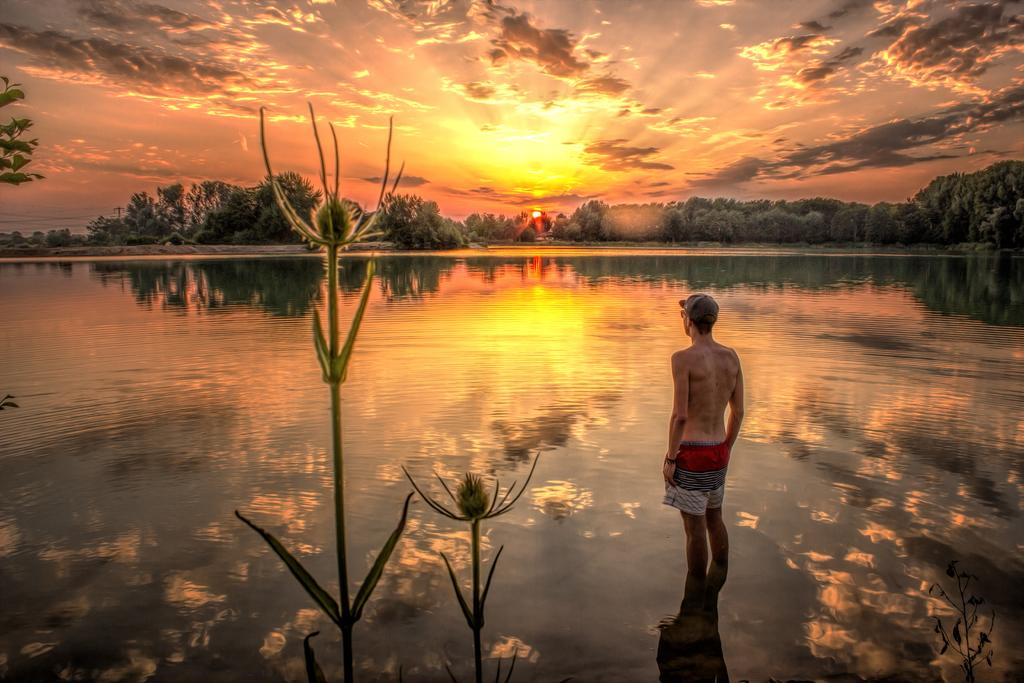What is the man in the image doing? The man is standing in the water. What can be seen in the image besides the man? There are trees visible in the image. What is visible in the background of the image? The sky is visible in the background of the image. How many pizzas are being served in the image? There are no pizzas present in the image. What type of stocking is the man wearing in the image? The man's legs are not visible in the image, so it is impossible to determine if he is wearing any stockings. 